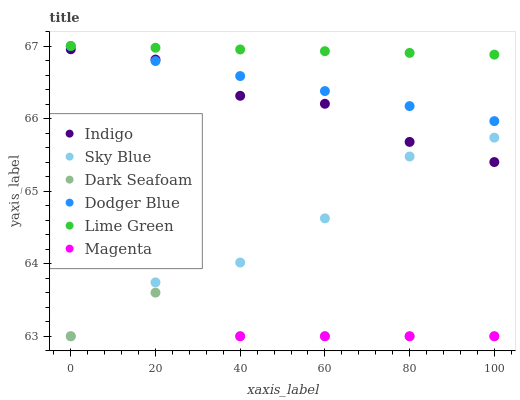Does Dark Seafoam have the minimum area under the curve?
Answer yes or no. Yes. Does Lime Green have the maximum area under the curve?
Answer yes or no. Yes. Does Dodger Blue have the minimum area under the curve?
Answer yes or no. No. Does Dodger Blue have the maximum area under the curve?
Answer yes or no. No. Is Lime Green the smoothest?
Answer yes or no. Yes. Is Magenta the roughest?
Answer yes or no. Yes. Is Dark Seafoam the smoothest?
Answer yes or no. No. Is Dark Seafoam the roughest?
Answer yes or no. No. Does Dark Seafoam have the lowest value?
Answer yes or no. Yes. Does Dodger Blue have the lowest value?
Answer yes or no. No. Does Lime Green have the highest value?
Answer yes or no. Yes. Does Dark Seafoam have the highest value?
Answer yes or no. No. Is Dark Seafoam less than Indigo?
Answer yes or no. Yes. Is Indigo greater than Magenta?
Answer yes or no. Yes. Does Sky Blue intersect Dark Seafoam?
Answer yes or no. Yes. Is Sky Blue less than Dark Seafoam?
Answer yes or no. No. Is Sky Blue greater than Dark Seafoam?
Answer yes or no. No. Does Dark Seafoam intersect Indigo?
Answer yes or no. No. 